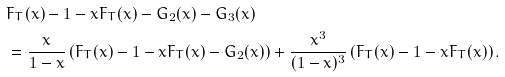<formula> <loc_0><loc_0><loc_500><loc_500>& F _ { T } ( x ) - 1 - x F _ { T } ( x ) - G _ { 2 } ( x ) - G _ { 3 } ( x ) \\ & = \frac { x } { 1 - x } \left ( F _ { T } ( x ) - 1 - x F _ { T } ( x ) - G _ { 2 } ( x ) \right ) + \frac { x ^ { 3 } } { ( 1 - x ) ^ { 3 } } \left ( F _ { T } ( x ) - 1 - x F _ { T } ( x ) \right ) .</formula> 